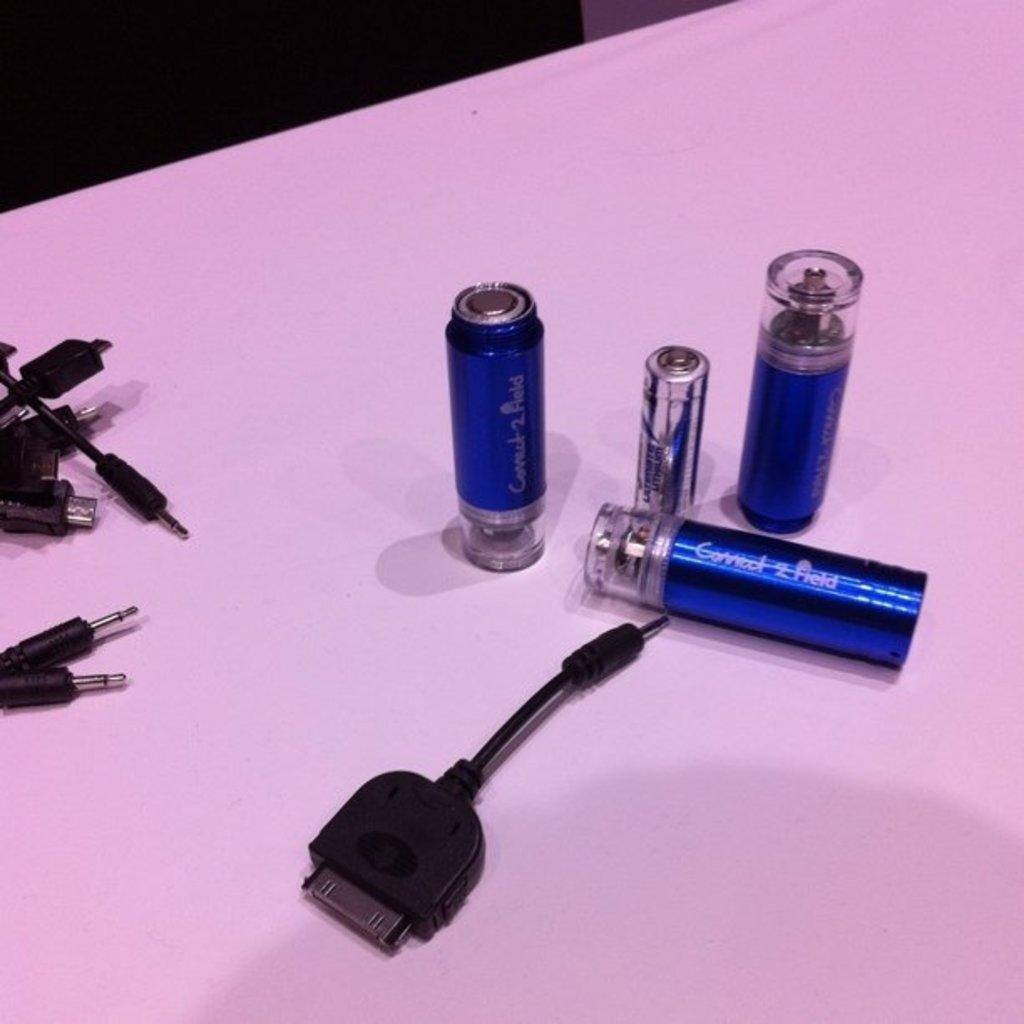<image>
Share a concise interpretation of the image provided. Cables and battery connectors called connect 2 Field 